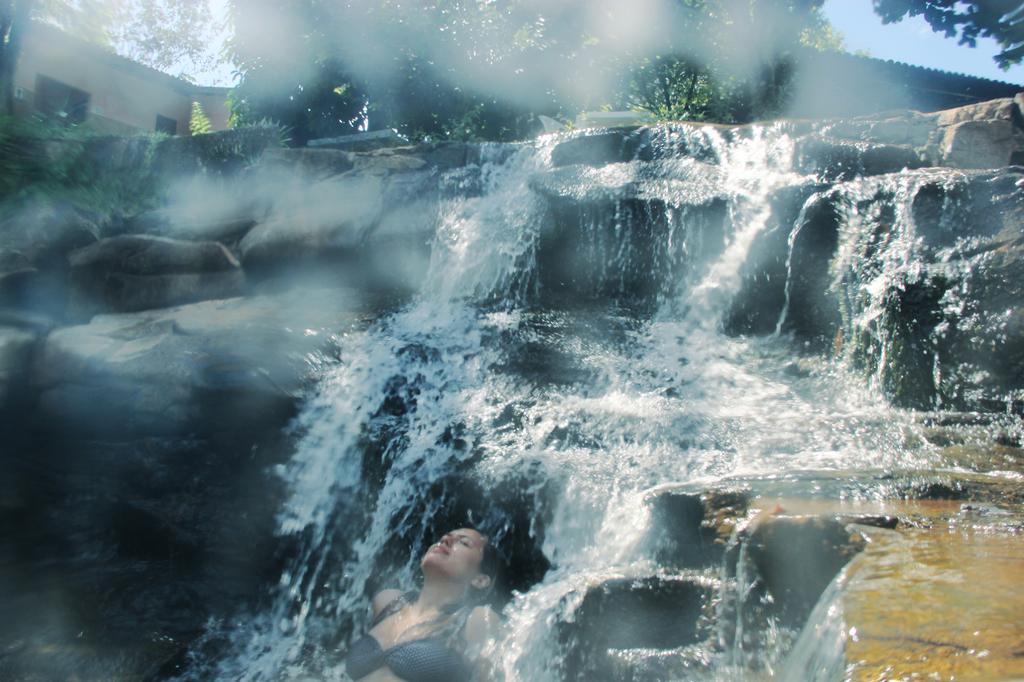Can you describe this image briefly? This image is taken outdoors. At the top of the image there is the sky. In the background there are two houses. There are a few trees with leaves, stems and branches. In the middle of the image there are many rocks and there is a waterfall with water. At the bottom of the image there is a woman swimming in the water. 